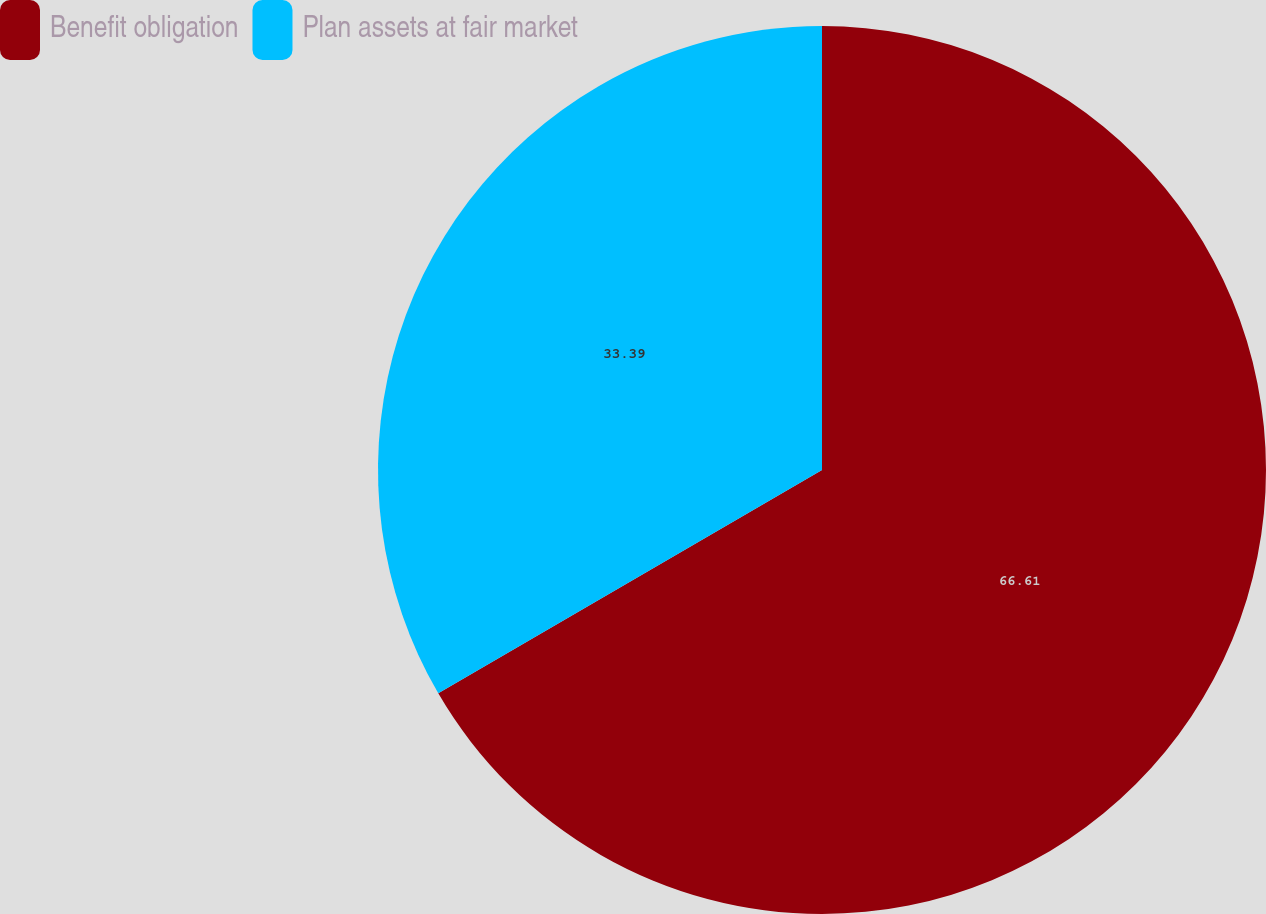<chart> <loc_0><loc_0><loc_500><loc_500><pie_chart><fcel>Benefit obligation<fcel>Plan assets at fair market<nl><fcel>66.61%<fcel>33.39%<nl></chart> 